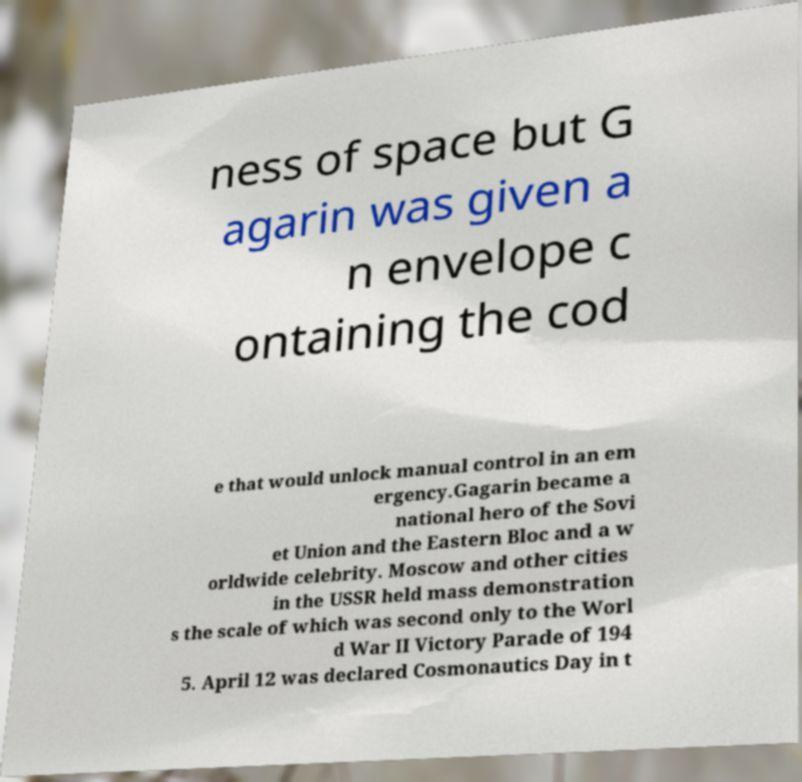Please identify and transcribe the text found in this image. ness of space but G agarin was given a n envelope c ontaining the cod e that would unlock manual control in an em ergency.Gagarin became a national hero of the Sovi et Union and the Eastern Bloc and a w orldwide celebrity. Moscow and other cities in the USSR held mass demonstration s the scale of which was second only to the Worl d War II Victory Parade of 194 5. April 12 was declared Cosmonautics Day in t 